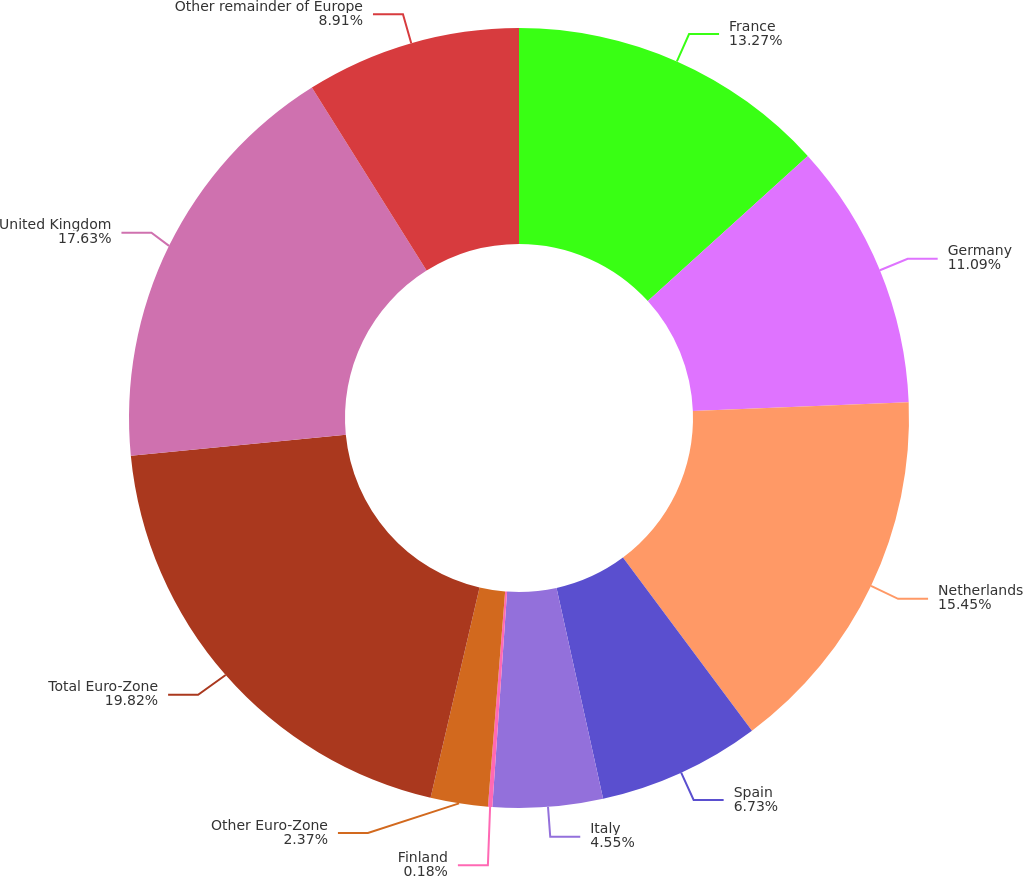<chart> <loc_0><loc_0><loc_500><loc_500><pie_chart><fcel>France<fcel>Germany<fcel>Netherlands<fcel>Spain<fcel>Italy<fcel>Finland<fcel>Other Euro-Zone<fcel>Total Euro-Zone<fcel>United Kingdom<fcel>Other remainder of Europe<nl><fcel>13.27%<fcel>11.09%<fcel>15.45%<fcel>6.73%<fcel>4.55%<fcel>0.18%<fcel>2.37%<fcel>19.82%<fcel>17.63%<fcel>8.91%<nl></chart> 